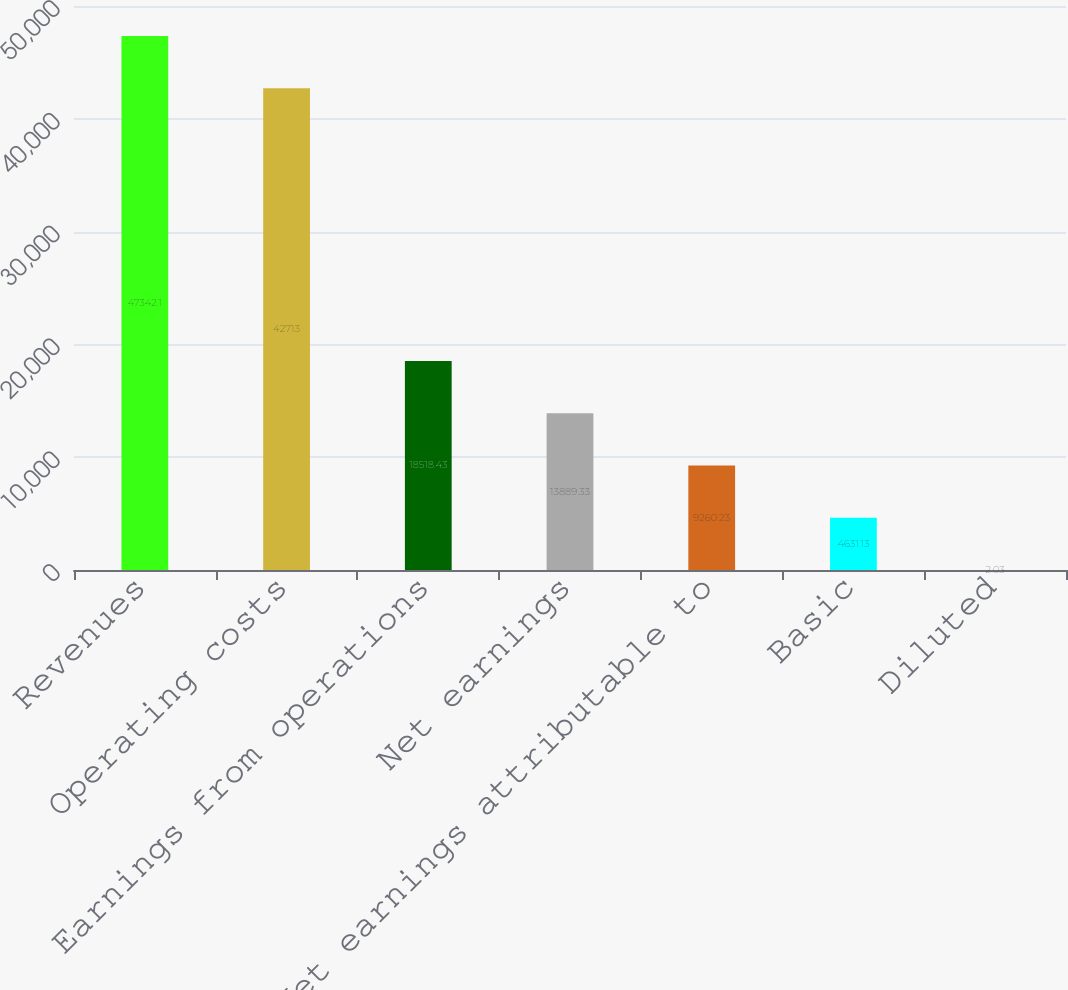Convert chart. <chart><loc_0><loc_0><loc_500><loc_500><bar_chart><fcel>Revenues<fcel>Operating costs<fcel>Earnings from operations<fcel>Net earnings<fcel>Net earnings attributable to<fcel>Basic<fcel>Diluted<nl><fcel>47342.1<fcel>42713<fcel>18518.4<fcel>13889.3<fcel>9260.23<fcel>4631.13<fcel>2.03<nl></chart> 